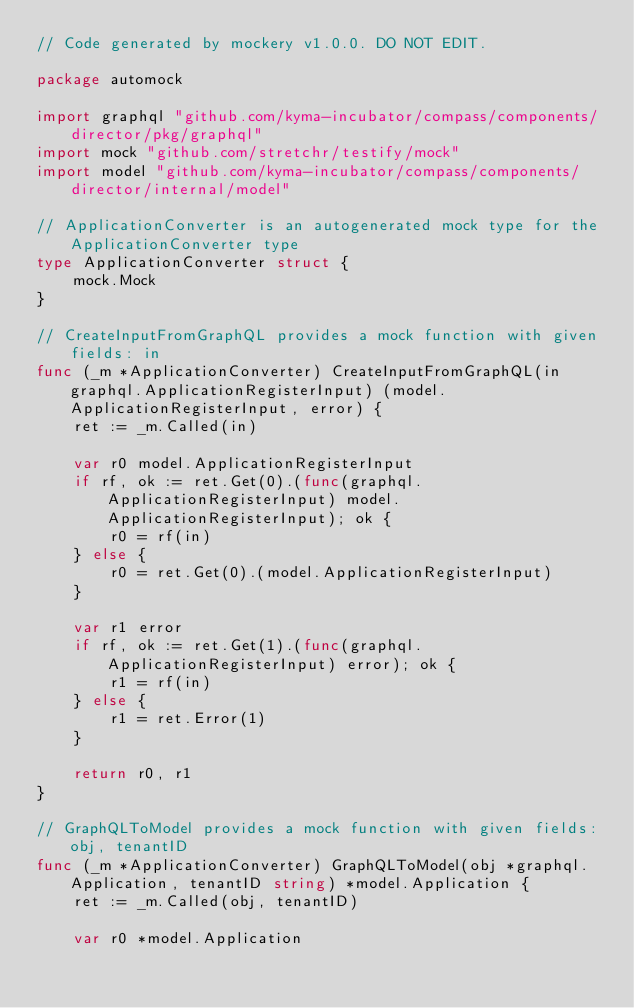Convert code to text. <code><loc_0><loc_0><loc_500><loc_500><_Go_>// Code generated by mockery v1.0.0. DO NOT EDIT.

package automock

import graphql "github.com/kyma-incubator/compass/components/director/pkg/graphql"
import mock "github.com/stretchr/testify/mock"
import model "github.com/kyma-incubator/compass/components/director/internal/model"

// ApplicationConverter is an autogenerated mock type for the ApplicationConverter type
type ApplicationConverter struct {
	mock.Mock
}

// CreateInputFromGraphQL provides a mock function with given fields: in
func (_m *ApplicationConverter) CreateInputFromGraphQL(in graphql.ApplicationRegisterInput) (model.ApplicationRegisterInput, error) {
	ret := _m.Called(in)

	var r0 model.ApplicationRegisterInput
	if rf, ok := ret.Get(0).(func(graphql.ApplicationRegisterInput) model.ApplicationRegisterInput); ok {
		r0 = rf(in)
	} else {
		r0 = ret.Get(0).(model.ApplicationRegisterInput)
	}

	var r1 error
	if rf, ok := ret.Get(1).(func(graphql.ApplicationRegisterInput) error); ok {
		r1 = rf(in)
	} else {
		r1 = ret.Error(1)
	}

	return r0, r1
}

// GraphQLToModel provides a mock function with given fields: obj, tenantID
func (_m *ApplicationConverter) GraphQLToModel(obj *graphql.Application, tenantID string) *model.Application {
	ret := _m.Called(obj, tenantID)

	var r0 *model.Application</code> 